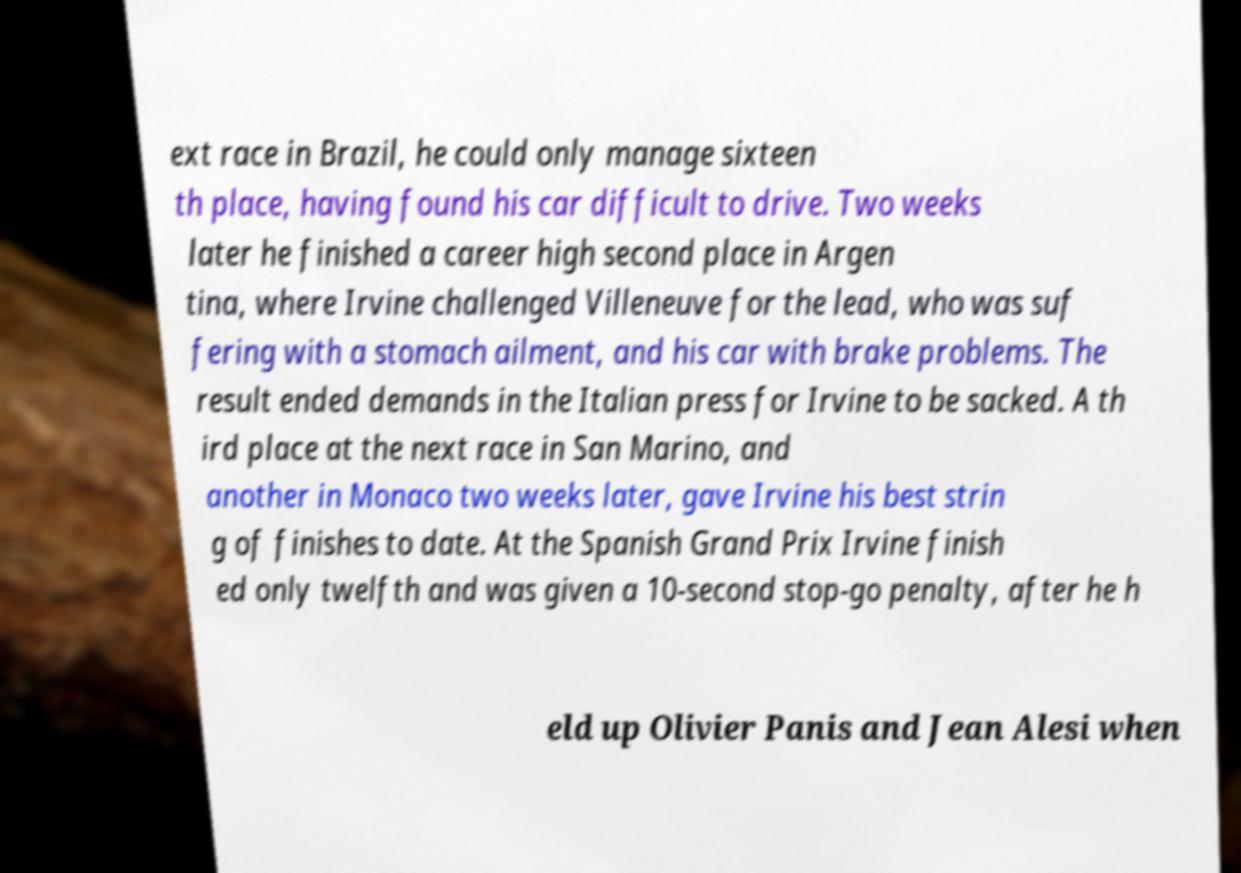Please identify and transcribe the text found in this image. ext race in Brazil, he could only manage sixteen th place, having found his car difficult to drive. Two weeks later he finished a career high second place in Argen tina, where Irvine challenged Villeneuve for the lead, who was suf fering with a stomach ailment, and his car with brake problems. The result ended demands in the Italian press for Irvine to be sacked. A th ird place at the next race in San Marino, and another in Monaco two weeks later, gave Irvine his best strin g of finishes to date. At the Spanish Grand Prix Irvine finish ed only twelfth and was given a 10-second stop-go penalty, after he h eld up Olivier Panis and Jean Alesi when 